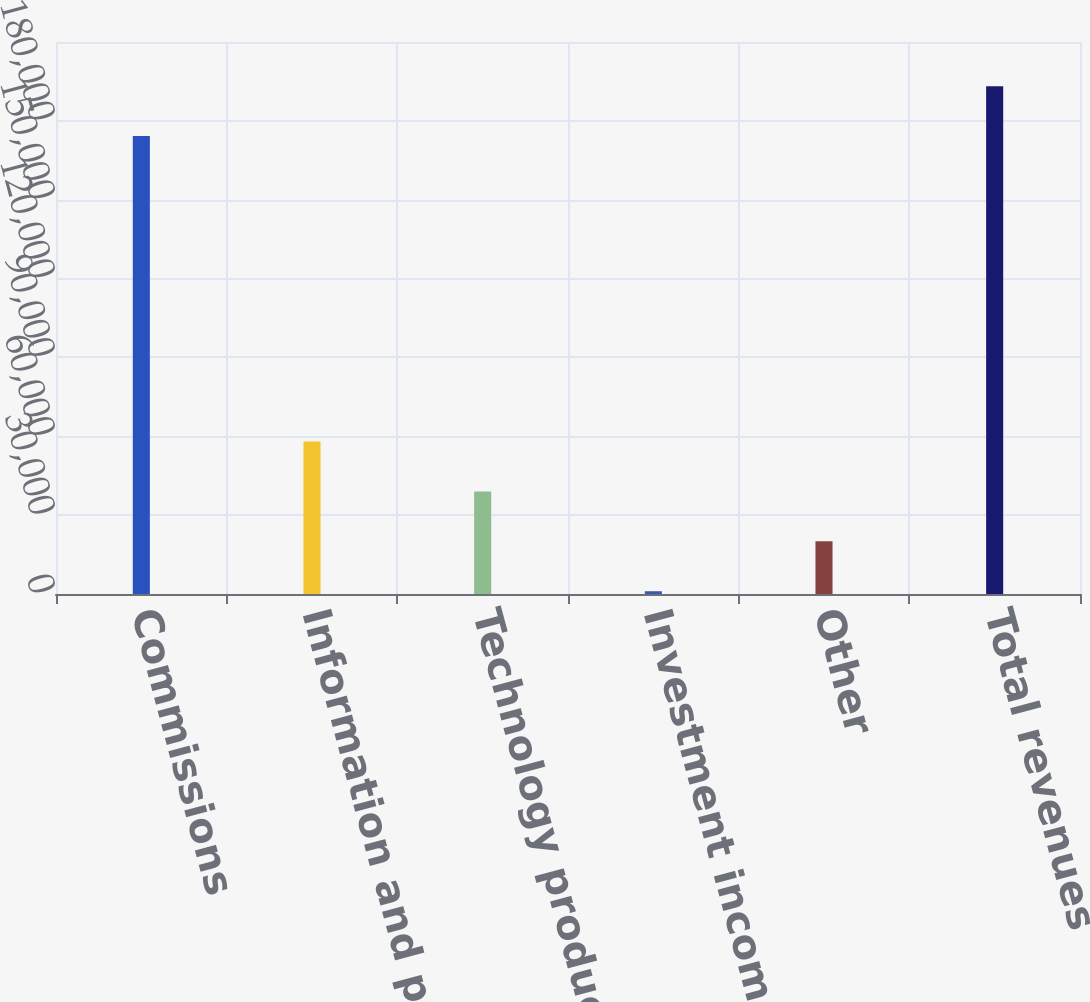Convert chart to OTSL. <chart><loc_0><loc_0><loc_500><loc_500><bar_chart><fcel>Commissions<fcel>Information and post-trade<fcel>Technology products and<fcel>Investment income<fcel>Other<fcel>Total revenues<nl><fcel>174199<fcel>57991.9<fcel>39013.6<fcel>1057<fcel>20035.3<fcel>193177<nl></chart> 